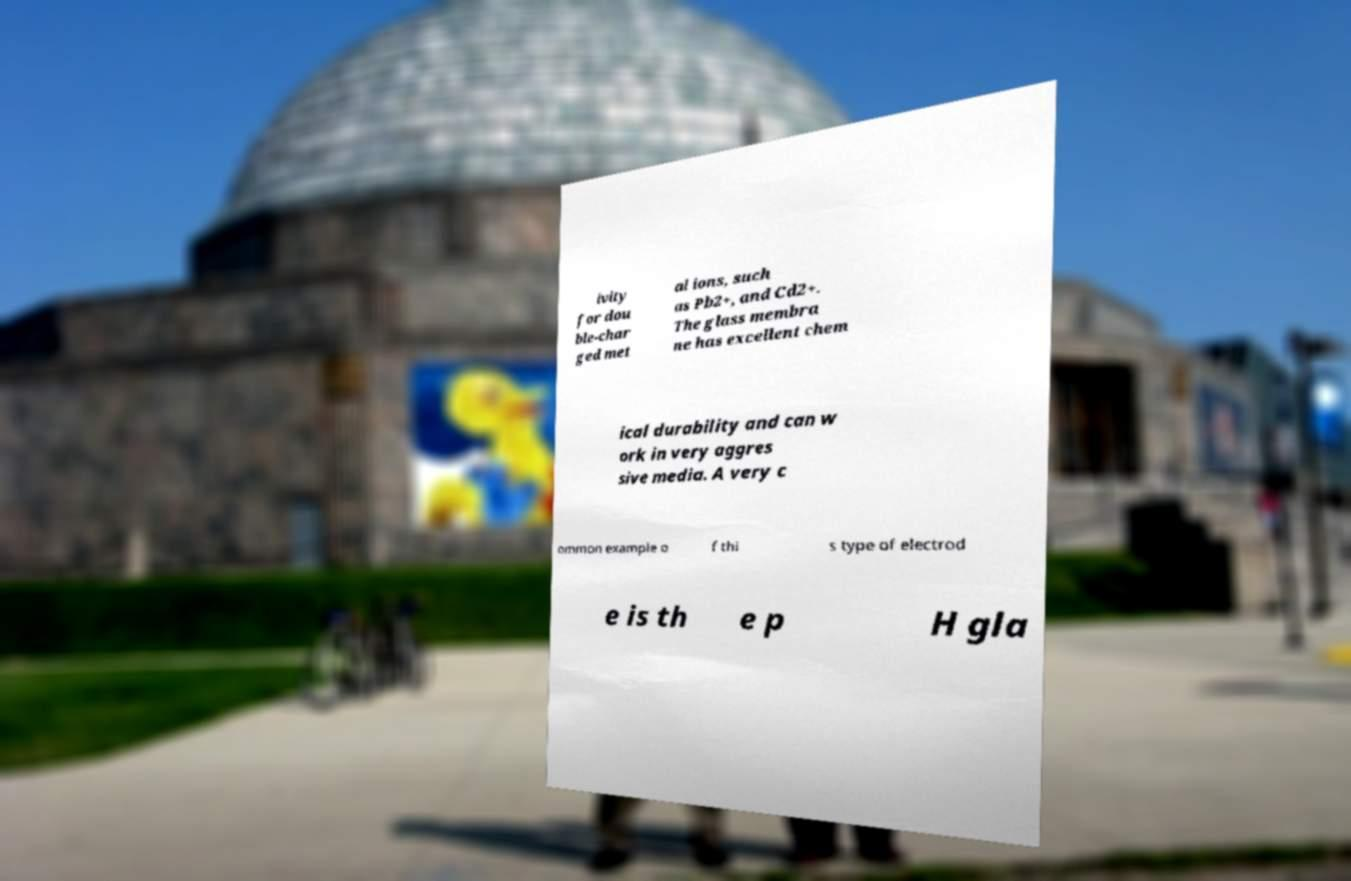What messages or text are displayed in this image? I need them in a readable, typed format. ivity for dou ble-char ged met al ions, such as Pb2+, and Cd2+. The glass membra ne has excellent chem ical durability and can w ork in very aggres sive media. A very c ommon example o f thi s type of electrod e is th e p H gla 